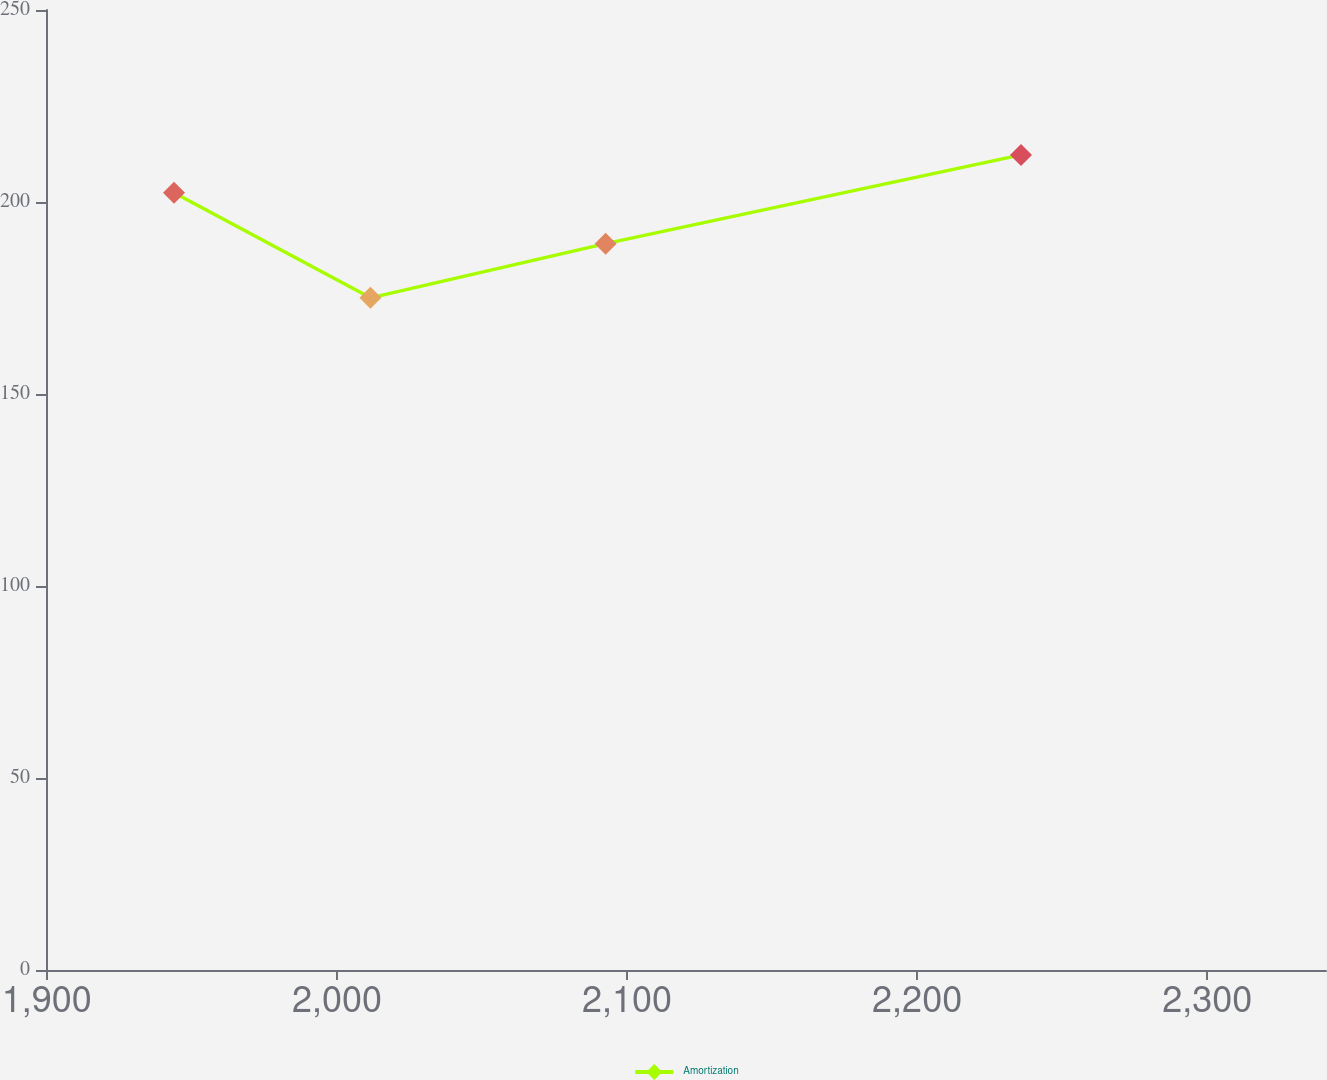Convert chart. <chart><loc_0><loc_0><loc_500><loc_500><line_chart><ecel><fcel>Amortization<nl><fcel>1943.84<fcel>202.41<nl><fcel>2011.56<fcel>175.04<nl><fcel>2092.62<fcel>189.14<nl><fcel>2235.81<fcel>212.27<nl><fcel>2385.06<fcel>109.65<nl></chart> 